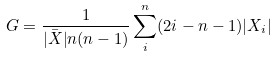<formula> <loc_0><loc_0><loc_500><loc_500>G = \frac { 1 } { \bar { | X | } n ( n - 1 ) } \sum ^ { n } _ { i } ( 2 i - n - 1 ) | X _ { i } |</formula> 